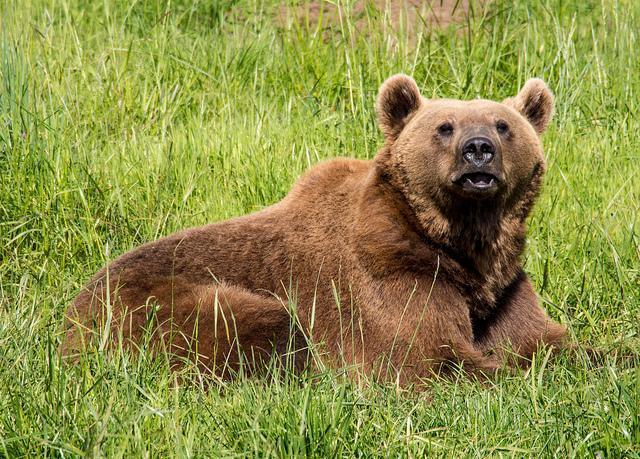How many ears on the bear?
Give a very brief answer. 2. 